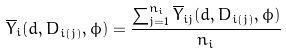<formula> <loc_0><loc_0><loc_500><loc_500>\overline { Y } _ { i } ( d , D _ { i ( j ) } , \phi ) = \frac { \sum _ { j = 1 } ^ { n _ { i } } \overline { Y } _ { i j } ( d , D _ { i ( j ) } , \phi ) } { n _ { i } }</formula> 